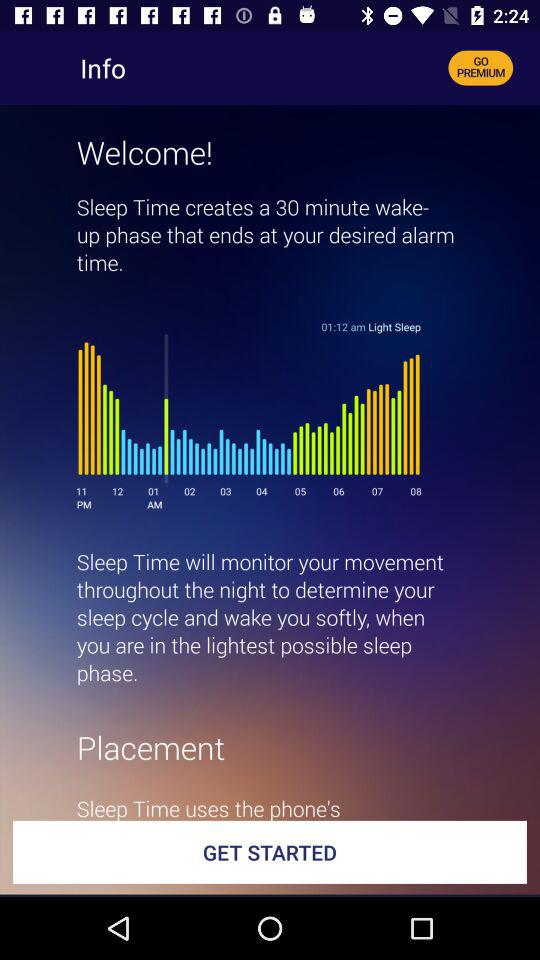What is the duration of the wake-up phase?
Answer the question using a single word or phrase. 30 minutes 